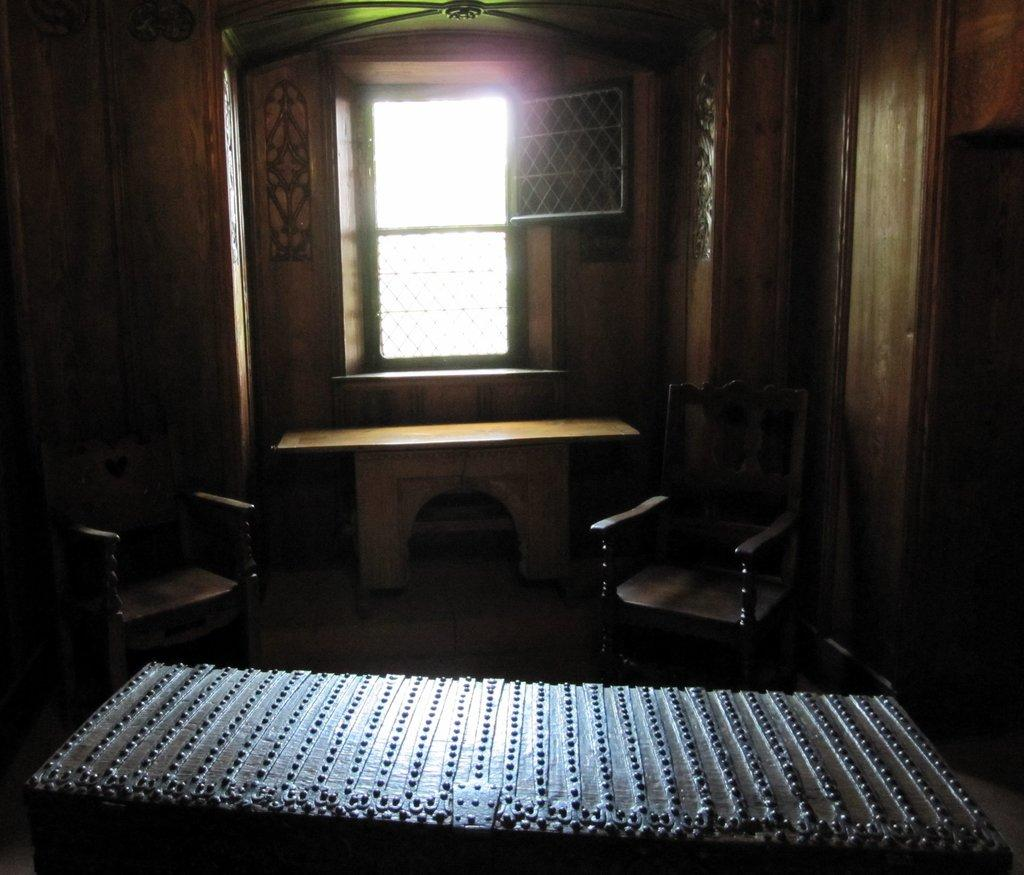How many chairs are in the image? There are two chairs in the image. What other furniture is present in the image? There is a table in the image. Can you describe the metal object in the image? There is a metal object in the image, but its specific purpose or appearance is not mentioned in the facts. What type of window is visible in the image? There is a window with grills in the image. Where is the window located in relation to the table? The window is located behind the table. What type of material is used for the walls surrounding the chairs? The walls surrounding the chairs are made of wood. What is the tendency of the chairs to start crying in the image? Chairs do not have the ability to cry, so this question is not applicable to the image. 